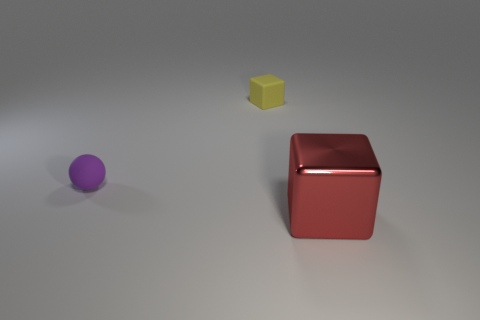What shape is the object that is the same size as the yellow rubber cube?
Your answer should be compact. Sphere. What number of yellow cubes are to the left of the red object?
Offer a very short reply. 1. Does the big thing have the same material as the tiny yellow thing?
Provide a short and direct response. No. How many things are in front of the purple sphere and on the left side of the large red shiny object?
Ensure brevity in your answer.  0. How many other things are there of the same color as the tiny ball?
Ensure brevity in your answer.  0. What number of yellow things are either tiny objects or cubes?
Your answer should be compact. 1. How big is the matte block?
Give a very brief answer. Small. What number of matte objects are tiny yellow objects or balls?
Your response must be concise. 2. Are there fewer small rubber things than small purple spheres?
Make the answer very short. No. How many other objects are there of the same material as the yellow thing?
Give a very brief answer. 1. 